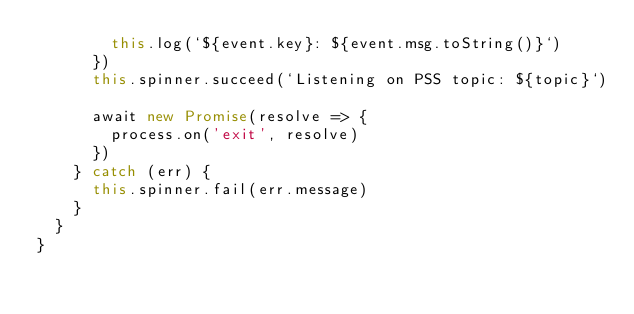<code> <loc_0><loc_0><loc_500><loc_500><_TypeScript_>        this.log(`${event.key}: ${event.msg.toString()}`)
      })
      this.spinner.succeed(`Listening on PSS topic: ${topic}`)

      await new Promise(resolve => {
        process.on('exit', resolve)
      })
    } catch (err) {
      this.spinner.fail(err.message)
    }
  }
}
</code> 